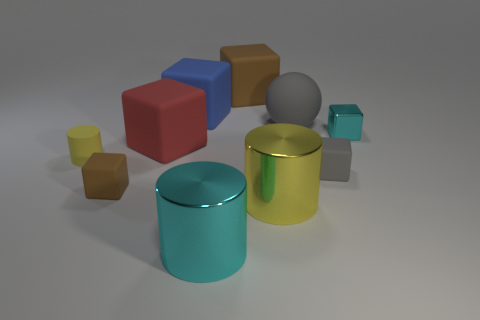Subtract all large cylinders. How many cylinders are left? 1 Subtract all red cubes. How many cubes are left? 5 Subtract all yellow blocks. How many yellow cylinders are left? 2 Subtract 3 cubes. How many cubes are left? 3 Subtract all green balls. Subtract all big matte spheres. How many objects are left? 9 Add 1 gray matte spheres. How many gray matte spheres are left? 2 Add 9 large blue cubes. How many large blue cubes exist? 10 Subtract 0 yellow cubes. How many objects are left? 10 Subtract all cubes. How many objects are left? 4 Subtract all blue blocks. Subtract all gray cylinders. How many blocks are left? 5 